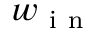Convert formula to latex. <formula><loc_0><loc_0><loc_500><loc_500>w _ { i n }</formula> 